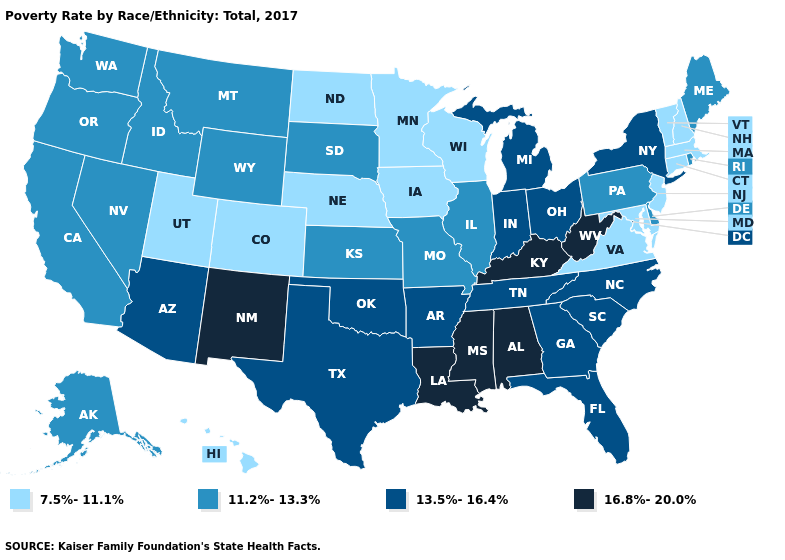Does Colorado have a higher value than Idaho?
Short answer required. No. Name the states that have a value in the range 11.2%-13.3%?
Short answer required. Alaska, California, Delaware, Idaho, Illinois, Kansas, Maine, Missouri, Montana, Nevada, Oregon, Pennsylvania, Rhode Island, South Dakota, Washington, Wyoming. Which states have the lowest value in the USA?
Give a very brief answer. Colorado, Connecticut, Hawaii, Iowa, Maryland, Massachusetts, Minnesota, Nebraska, New Hampshire, New Jersey, North Dakota, Utah, Vermont, Virginia, Wisconsin. Among the states that border West Virginia , does Kentucky have the highest value?
Concise answer only. Yes. What is the highest value in the West ?
Keep it brief. 16.8%-20.0%. How many symbols are there in the legend?
Keep it brief. 4. What is the value of Louisiana?
Concise answer only. 16.8%-20.0%. What is the lowest value in states that border Oregon?
Short answer required. 11.2%-13.3%. What is the value of Kansas?
Concise answer only. 11.2%-13.3%. What is the lowest value in states that border Nevada?
Concise answer only. 7.5%-11.1%. What is the highest value in the West ?
Give a very brief answer. 16.8%-20.0%. What is the highest value in states that border North Carolina?
Give a very brief answer. 13.5%-16.4%. Does Florida have the same value as Iowa?
Short answer required. No. Does Ohio have the lowest value in the MidWest?
Write a very short answer. No. Does Alaska have the lowest value in the West?
Short answer required. No. 